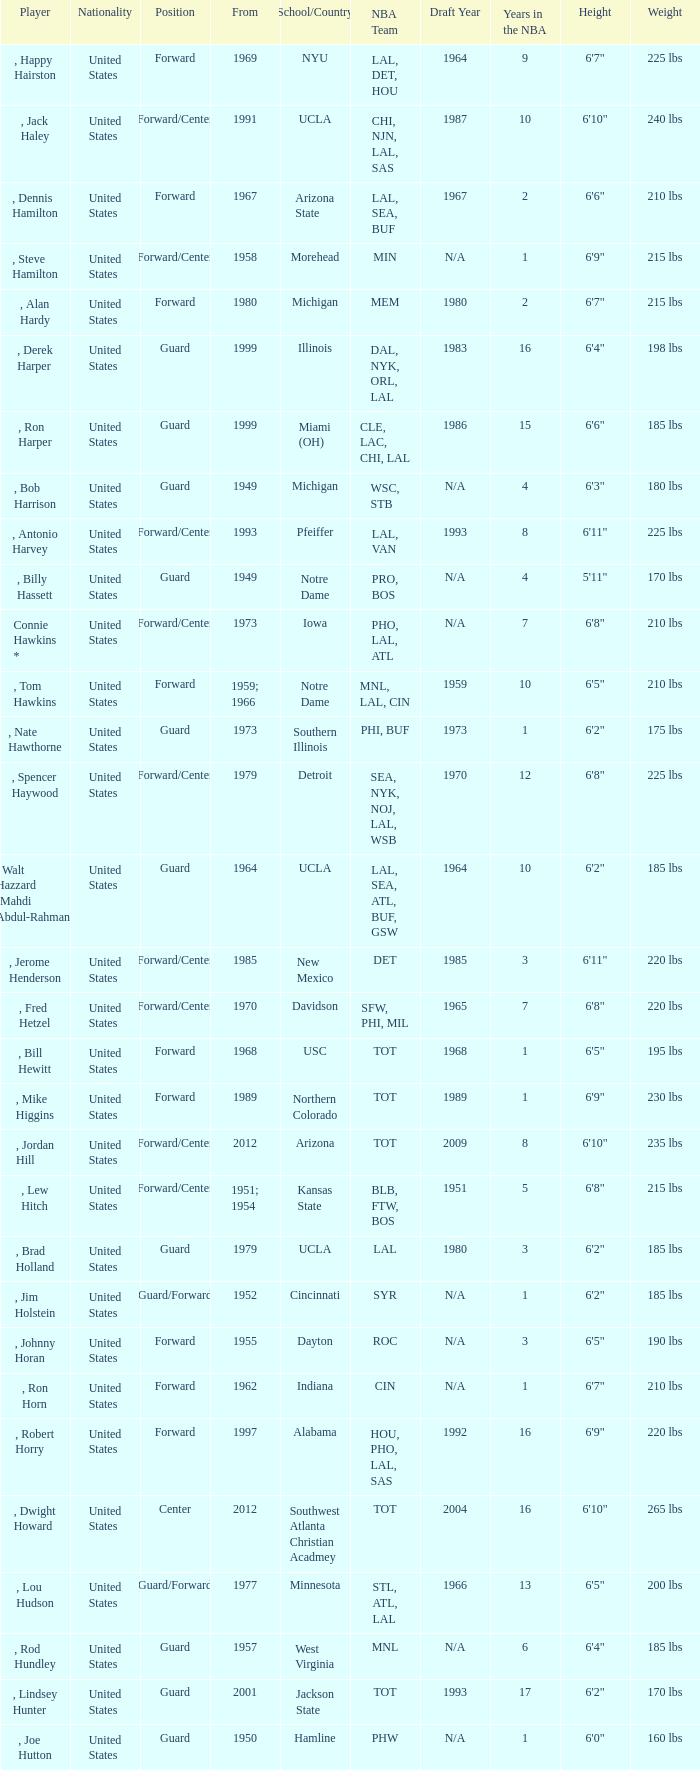What position was for Arizona State? Forward. 